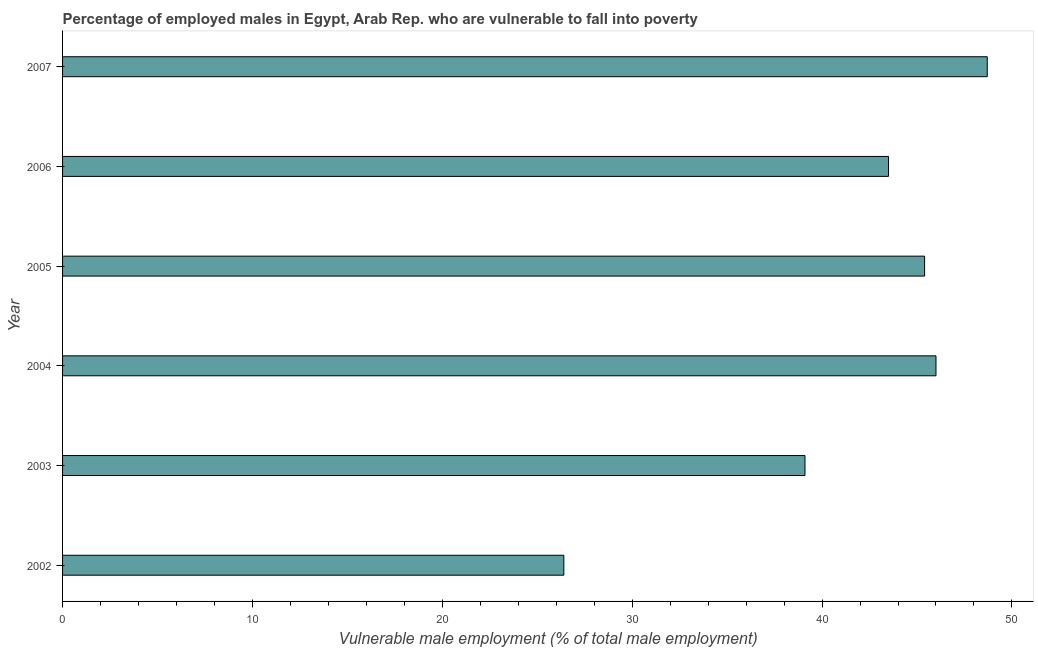Does the graph contain any zero values?
Ensure brevity in your answer.  No. What is the title of the graph?
Make the answer very short. Percentage of employed males in Egypt, Arab Rep. who are vulnerable to fall into poverty. What is the label or title of the X-axis?
Offer a terse response. Vulnerable male employment (% of total male employment). Across all years, what is the maximum percentage of employed males who are vulnerable to fall into poverty?
Keep it short and to the point. 48.7. Across all years, what is the minimum percentage of employed males who are vulnerable to fall into poverty?
Provide a succinct answer. 26.4. In which year was the percentage of employed males who are vulnerable to fall into poverty maximum?
Your answer should be very brief. 2007. In which year was the percentage of employed males who are vulnerable to fall into poverty minimum?
Keep it short and to the point. 2002. What is the sum of the percentage of employed males who are vulnerable to fall into poverty?
Your response must be concise. 249.1. What is the average percentage of employed males who are vulnerable to fall into poverty per year?
Provide a succinct answer. 41.52. What is the median percentage of employed males who are vulnerable to fall into poverty?
Your answer should be very brief. 44.45. In how many years, is the percentage of employed males who are vulnerable to fall into poverty greater than 36 %?
Offer a terse response. 5. Do a majority of the years between 2003 and 2005 (inclusive) have percentage of employed males who are vulnerable to fall into poverty greater than 20 %?
Your response must be concise. Yes. What is the ratio of the percentage of employed males who are vulnerable to fall into poverty in 2002 to that in 2003?
Give a very brief answer. 0.68. Is the difference between the percentage of employed males who are vulnerable to fall into poverty in 2004 and 2007 greater than the difference between any two years?
Your answer should be very brief. No. What is the difference between the highest and the second highest percentage of employed males who are vulnerable to fall into poverty?
Offer a terse response. 2.7. Is the sum of the percentage of employed males who are vulnerable to fall into poverty in 2002 and 2006 greater than the maximum percentage of employed males who are vulnerable to fall into poverty across all years?
Keep it short and to the point. Yes. What is the difference between the highest and the lowest percentage of employed males who are vulnerable to fall into poverty?
Your response must be concise. 22.3. In how many years, is the percentage of employed males who are vulnerable to fall into poverty greater than the average percentage of employed males who are vulnerable to fall into poverty taken over all years?
Offer a very short reply. 4. How many bars are there?
Provide a short and direct response. 6. How many years are there in the graph?
Offer a terse response. 6. Are the values on the major ticks of X-axis written in scientific E-notation?
Ensure brevity in your answer.  No. What is the Vulnerable male employment (% of total male employment) of 2002?
Make the answer very short. 26.4. What is the Vulnerable male employment (% of total male employment) of 2003?
Your response must be concise. 39.1. What is the Vulnerable male employment (% of total male employment) in 2005?
Give a very brief answer. 45.4. What is the Vulnerable male employment (% of total male employment) in 2006?
Provide a short and direct response. 43.5. What is the Vulnerable male employment (% of total male employment) of 2007?
Make the answer very short. 48.7. What is the difference between the Vulnerable male employment (% of total male employment) in 2002 and 2004?
Keep it short and to the point. -19.6. What is the difference between the Vulnerable male employment (% of total male employment) in 2002 and 2006?
Give a very brief answer. -17.1. What is the difference between the Vulnerable male employment (% of total male employment) in 2002 and 2007?
Your answer should be compact. -22.3. What is the difference between the Vulnerable male employment (% of total male employment) in 2003 and 2005?
Give a very brief answer. -6.3. What is the difference between the Vulnerable male employment (% of total male employment) in 2003 and 2006?
Make the answer very short. -4.4. What is the difference between the Vulnerable male employment (% of total male employment) in 2004 and 2006?
Offer a terse response. 2.5. What is the difference between the Vulnerable male employment (% of total male employment) in 2004 and 2007?
Your answer should be compact. -2.7. What is the difference between the Vulnerable male employment (% of total male employment) in 2005 and 2007?
Offer a very short reply. -3.3. What is the ratio of the Vulnerable male employment (% of total male employment) in 2002 to that in 2003?
Provide a short and direct response. 0.68. What is the ratio of the Vulnerable male employment (% of total male employment) in 2002 to that in 2004?
Provide a succinct answer. 0.57. What is the ratio of the Vulnerable male employment (% of total male employment) in 2002 to that in 2005?
Make the answer very short. 0.58. What is the ratio of the Vulnerable male employment (% of total male employment) in 2002 to that in 2006?
Ensure brevity in your answer.  0.61. What is the ratio of the Vulnerable male employment (% of total male employment) in 2002 to that in 2007?
Your response must be concise. 0.54. What is the ratio of the Vulnerable male employment (% of total male employment) in 2003 to that in 2004?
Provide a short and direct response. 0.85. What is the ratio of the Vulnerable male employment (% of total male employment) in 2003 to that in 2005?
Give a very brief answer. 0.86. What is the ratio of the Vulnerable male employment (% of total male employment) in 2003 to that in 2006?
Keep it short and to the point. 0.9. What is the ratio of the Vulnerable male employment (% of total male employment) in 2003 to that in 2007?
Provide a succinct answer. 0.8. What is the ratio of the Vulnerable male employment (% of total male employment) in 2004 to that in 2006?
Your response must be concise. 1.06. What is the ratio of the Vulnerable male employment (% of total male employment) in 2004 to that in 2007?
Make the answer very short. 0.94. What is the ratio of the Vulnerable male employment (% of total male employment) in 2005 to that in 2006?
Make the answer very short. 1.04. What is the ratio of the Vulnerable male employment (% of total male employment) in 2005 to that in 2007?
Your response must be concise. 0.93. What is the ratio of the Vulnerable male employment (% of total male employment) in 2006 to that in 2007?
Your response must be concise. 0.89. 